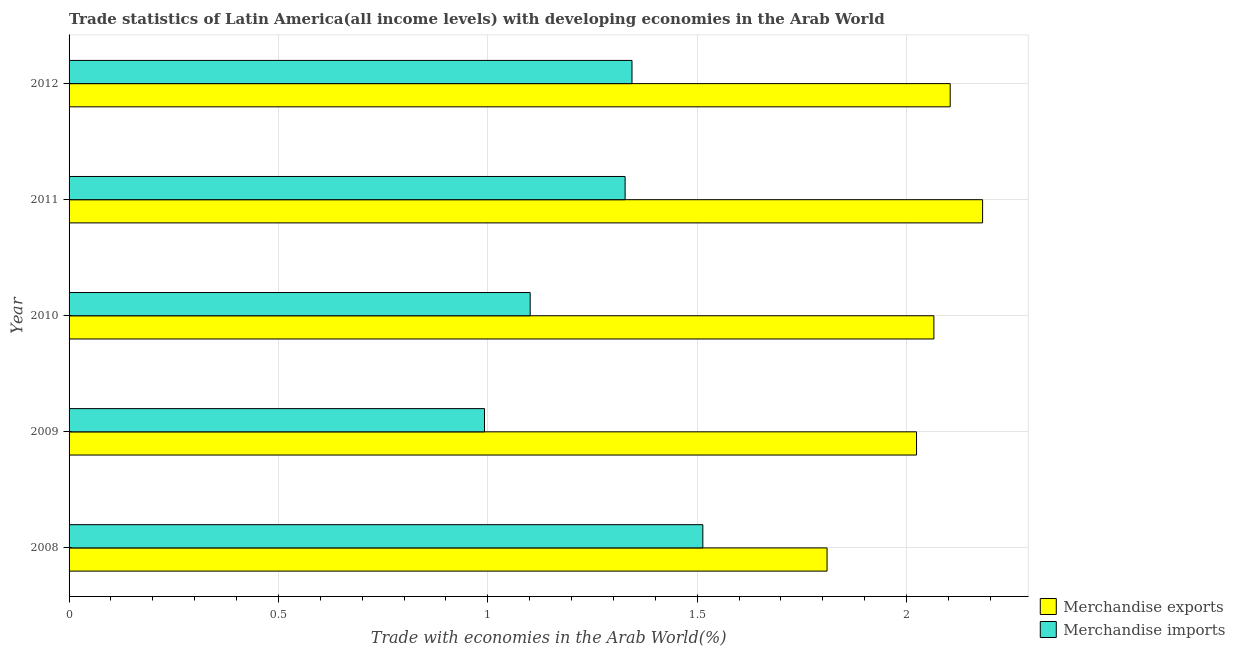Are the number of bars per tick equal to the number of legend labels?
Your answer should be compact. Yes. What is the label of the 3rd group of bars from the top?
Offer a terse response. 2010. In how many cases, is the number of bars for a given year not equal to the number of legend labels?
Keep it short and to the point. 0. What is the merchandise imports in 2010?
Your answer should be compact. 1.1. Across all years, what is the maximum merchandise exports?
Your answer should be very brief. 2.18. Across all years, what is the minimum merchandise exports?
Provide a succinct answer. 1.81. In which year was the merchandise imports minimum?
Keep it short and to the point. 2009. What is the total merchandise imports in the graph?
Your answer should be very brief. 6.28. What is the difference between the merchandise imports in 2008 and that in 2010?
Your response must be concise. 0.41. What is the difference between the merchandise exports in 2010 and the merchandise imports in 2011?
Make the answer very short. 0.74. What is the average merchandise exports per year?
Offer a very short reply. 2.04. In the year 2012, what is the difference between the merchandise imports and merchandise exports?
Your answer should be compact. -0.76. In how many years, is the merchandise imports greater than 1.5 %?
Make the answer very short. 1. What is the ratio of the merchandise exports in 2010 to that in 2011?
Give a very brief answer. 0.95. What is the difference between the highest and the second highest merchandise exports?
Your answer should be compact. 0.08. What is the difference between the highest and the lowest merchandise exports?
Ensure brevity in your answer.  0.37. In how many years, is the merchandise exports greater than the average merchandise exports taken over all years?
Offer a terse response. 3. Are all the bars in the graph horizontal?
Provide a succinct answer. Yes. How many years are there in the graph?
Keep it short and to the point. 5. Are the values on the major ticks of X-axis written in scientific E-notation?
Provide a short and direct response. No. Does the graph contain any zero values?
Give a very brief answer. No. Where does the legend appear in the graph?
Keep it short and to the point. Bottom right. How are the legend labels stacked?
Offer a very short reply. Vertical. What is the title of the graph?
Provide a short and direct response. Trade statistics of Latin America(all income levels) with developing economies in the Arab World. What is the label or title of the X-axis?
Your response must be concise. Trade with economies in the Arab World(%). What is the Trade with economies in the Arab World(%) in Merchandise exports in 2008?
Keep it short and to the point. 1.81. What is the Trade with economies in the Arab World(%) of Merchandise imports in 2008?
Provide a short and direct response. 1.51. What is the Trade with economies in the Arab World(%) in Merchandise exports in 2009?
Your answer should be compact. 2.02. What is the Trade with economies in the Arab World(%) of Merchandise imports in 2009?
Offer a terse response. 0.99. What is the Trade with economies in the Arab World(%) in Merchandise exports in 2010?
Offer a terse response. 2.07. What is the Trade with economies in the Arab World(%) in Merchandise imports in 2010?
Offer a terse response. 1.1. What is the Trade with economies in the Arab World(%) in Merchandise exports in 2011?
Provide a succinct answer. 2.18. What is the Trade with economies in the Arab World(%) of Merchandise imports in 2011?
Your answer should be compact. 1.33. What is the Trade with economies in the Arab World(%) in Merchandise exports in 2012?
Your response must be concise. 2.1. What is the Trade with economies in the Arab World(%) in Merchandise imports in 2012?
Give a very brief answer. 1.34. Across all years, what is the maximum Trade with economies in the Arab World(%) in Merchandise exports?
Provide a succinct answer. 2.18. Across all years, what is the maximum Trade with economies in the Arab World(%) of Merchandise imports?
Your response must be concise. 1.51. Across all years, what is the minimum Trade with economies in the Arab World(%) of Merchandise exports?
Your answer should be compact. 1.81. Across all years, what is the minimum Trade with economies in the Arab World(%) in Merchandise imports?
Keep it short and to the point. 0.99. What is the total Trade with economies in the Arab World(%) of Merchandise exports in the graph?
Ensure brevity in your answer.  10.19. What is the total Trade with economies in the Arab World(%) in Merchandise imports in the graph?
Ensure brevity in your answer.  6.28. What is the difference between the Trade with economies in the Arab World(%) in Merchandise exports in 2008 and that in 2009?
Offer a terse response. -0.21. What is the difference between the Trade with economies in the Arab World(%) in Merchandise imports in 2008 and that in 2009?
Your answer should be very brief. 0.52. What is the difference between the Trade with economies in the Arab World(%) in Merchandise exports in 2008 and that in 2010?
Your answer should be very brief. -0.26. What is the difference between the Trade with economies in the Arab World(%) of Merchandise imports in 2008 and that in 2010?
Your answer should be very brief. 0.41. What is the difference between the Trade with economies in the Arab World(%) in Merchandise exports in 2008 and that in 2011?
Your answer should be very brief. -0.37. What is the difference between the Trade with economies in the Arab World(%) of Merchandise imports in 2008 and that in 2011?
Keep it short and to the point. 0.19. What is the difference between the Trade with economies in the Arab World(%) in Merchandise exports in 2008 and that in 2012?
Make the answer very short. -0.29. What is the difference between the Trade with economies in the Arab World(%) of Merchandise imports in 2008 and that in 2012?
Your answer should be compact. 0.17. What is the difference between the Trade with economies in the Arab World(%) in Merchandise exports in 2009 and that in 2010?
Give a very brief answer. -0.04. What is the difference between the Trade with economies in the Arab World(%) in Merchandise imports in 2009 and that in 2010?
Ensure brevity in your answer.  -0.11. What is the difference between the Trade with economies in the Arab World(%) in Merchandise exports in 2009 and that in 2011?
Your answer should be very brief. -0.16. What is the difference between the Trade with economies in the Arab World(%) of Merchandise imports in 2009 and that in 2011?
Make the answer very short. -0.34. What is the difference between the Trade with economies in the Arab World(%) in Merchandise exports in 2009 and that in 2012?
Provide a succinct answer. -0.08. What is the difference between the Trade with economies in the Arab World(%) of Merchandise imports in 2009 and that in 2012?
Your response must be concise. -0.35. What is the difference between the Trade with economies in the Arab World(%) of Merchandise exports in 2010 and that in 2011?
Give a very brief answer. -0.12. What is the difference between the Trade with economies in the Arab World(%) in Merchandise imports in 2010 and that in 2011?
Offer a terse response. -0.23. What is the difference between the Trade with economies in the Arab World(%) in Merchandise exports in 2010 and that in 2012?
Offer a very short reply. -0.04. What is the difference between the Trade with economies in the Arab World(%) in Merchandise imports in 2010 and that in 2012?
Ensure brevity in your answer.  -0.24. What is the difference between the Trade with economies in the Arab World(%) of Merchandise exports in 2011 and that in 2012?
Your answer should be compact. 0.08. What is the difference between the Trade with economies in the Arab World(%) of Merchandise imports in 2011 and that in 2012?
Provide a succinct answer. -0.02. What is the difference between the Trade with economies in the Arab World(%) in Merchandise exports in 2008 and the Trade with economies in the Arab World(%) in Merchandise imports in 2009?
Your answer should be very brief. 0.82. What is the difference between the Trade with economies in the Arab World(%) of Merchandise exports in 2008 and the Trade with economies in the Arab World(%) of Merchandise imports in 2010?
Provide a succinct answer. 0.71. What is the difference between the Trade with economies in the Arab World(%) of Merchandise exports in 2008 and the Trade with economies in the Arab World(%) of Merchandise imports in 2011?
Offer a very short reply. 0.48. What is the difference between the Trade with economies in the Arab World(%) in Merchandise exports in 2008 and the Trade with economies in the Arab World(%) in Merchandise imports in 2012?
Make the answer very short. 0.47. What is the difference between the Trade with economies in the Arab World(%) of Merchandise exports in 2009 and the Trade with economies in the Arab World(%) of Merchandise imports in 2010?
Your answer should be compact. 0.92. What is the difference between the Trade with economies in the Arab World(%) of Merchandise exports in 2009 and the Trade with economies in the Arab World(%) of Merchandise imports in 2011?
Offer a very short reply. 0.7. What is the difference between the Trade with economies in the Arab World(%) of Merchandise exports in 2009 and the Trade with economies in the Arab World(%) of Merchandise imports in 2012?
Ensure brevity in your answer.  0.68. What is the difference between the Trade with economies in the Arab World(%) of Merchandise exports in 2010 and the Trade with economies in the Arab World(%) of Merchandise imports in 2011?
Your answer should be compact. 0.74. What is the difference between the Trade with economies in the Arab World(%) of Merchandise exports in 2010 and the Trade with economies in the Arab World(%) of Merchandise imports in 2012?
Offer a terse response. 0.72. What is the difference between the Trade with economies in the Arab World(%) of Merchandise exports in 2011 and the Trade with economies in the Arab World(%) of Merchandise imports in 2012?
Ensure brevity in your answer.  0.84. What is the average Trade with economies in the Arab World(%) of Merchandise exports per year?
Your answer should be compact. 2.04. What is the average Trade with economies in the Arab World(%) in Merchandise imports per year?
Make the answer very short. 1.26. In the year 2008, what is the difference between the Trade with economies in the Arab World(%) of Merchandise exports and Trade with economies in the Arab World(%) of Merchandise imports?
Keep it short and to the point. 0.3. In the year 2009, what is the difference between the Trade with economies in the Arab World(%) of Merchandise exports and Trade with economies in the Arab World(%) of Merchandise imports?
Give a very brief answer. 1.03. In the year 2010, what is the difference between the Trade with economies in the Arab World(%) in Merchandise exports and Trade with economies in the Arab World(%) in Merchandise imports?
Offer a terse response. 0.96. In the year 2011, what is the difference between the Trade with economies in the Arab World(%) of Merchandise exports and Trade with economies in the Arab World(%) of Merchandise imports?
Your answer should be very brief. 0.85. In the year 2012, what is the difference between the Trade with economies in the Arab World(%) of Merchandise exports and Trade with economies in the Arab World(%) of Merchandise imports?
Provide a succinct answer. 0.76. What is the ratio of the Trade with economies in the Arab World(%) in Merchandise exports in 2008 to that in 2009?
Your answer should be very brief. 0.89. What is the ratio of the Trade with economies in the Arab World(%) in Merchandise imports in 2008 to that in 2009?
Keep it short and to the point. 1.53. What is the ratio of the Trade with economies in the Arab World(%) in Merchandise exports in 2008 to that in 2010?
Provide a short and direct response. 0.88. What is the ratio of the Trade with economies in the Arab World(%) in Merchandise imports in 2008 to that in 2010?
Give a very brief answer. 1.37. What is the ratio of the Trade with economies in the Arab World(%) in Merchandise exports in 2008 to that in 2011?
Provide a succinct answer. 0.83. What is the ratio of the Trade with economies in the Arab World(%) of Merchandise imports in 2008 to that in 2011?
Give a very brief answer. 1.14. What is the ratio of the Trade with economies in the Arab World(%) of Merchandise exports in 2008 to that in 2012?
Your answer should be very brief. 0.86. What is the ratio of the Trade with economies in the Arab World(%) in Merchandise imports in 2008 to that in 2012?
Offer a terse response. 1.13. What is the ratio of the Trade with economies in the Arab World(%) of Merchandise exports in 2009 to that in 2010?
Keep it short and to the point. 0.98. What is the ratio of the Trade with economies in the Arab World(%) in Merchandise imports in 2009 to that in 2010?
Provide a succinct answer. 0.9. What is the ratio of the Trade with economies in the Arab World(%) of Merchandise exports in 2009 to that in 2011?
Your response must be concise. 0.93. What is the ratio of the Trade with economies in the Arab World(%) in Merchandise imports in 2009 to that in 2011?
Your answer should be compact. 0.75. What is the ratio of the Trade with economies in the Arab World(%) in Merchandise exports in 2009 to that in 2012?
Ensure brevity in your answer.  0.96. What is the ratio of the Trade with economies in the Arab World(%) in Merchandise imports in 2009 to that in 2012?
Ensure brevity in your answer.  0.74. What is the ratio of the Trade with economies in the Arab World(%) of Merchandise exports in 2010 to that in 2011?
Ensure brevity in your answer.  0.95. What is the ratio of the Trade with economies in the Arab World(%) of Merchandise imports in 2010 to that in 2011?
Ensure brevity in your answer.  0.83. What is the ratio of the Trade with economies in the Arab World(%) of Merchandise exports in 2010 to that in 2012?
Offer a very short reply. 0.98. What is the ratio of the Trade with economies in the Arab World(%) of Merchandise imports in 2010 to that in 2012?
Your answer should be very brief. 0.82. What is the ratio of the Trade with economies in the Arab World(%) in Merchandise exports in 2011 to that in 2012?
Ensure brevity in your answer.  1.04. What is the difference between the highest and the second highest Trade with economies in the Arab World(%) of Merchandise exports?
Your answer should be very brief. 0.08. What is the difference between the highest and the second highest Trade with economies in the Arab World(%) of Merchandise imports?
Give a very brief answer. 0.17. What is the difference between the highest and the lowest Trade with economies in the Arab World(%) in Merchandise exports?
Offer a terse response. 0.37. What is the difference between the highest and the lowest Trade with economies in the Arab World(%) of Merchandise imports?
Your response must be concise. 0.52. 